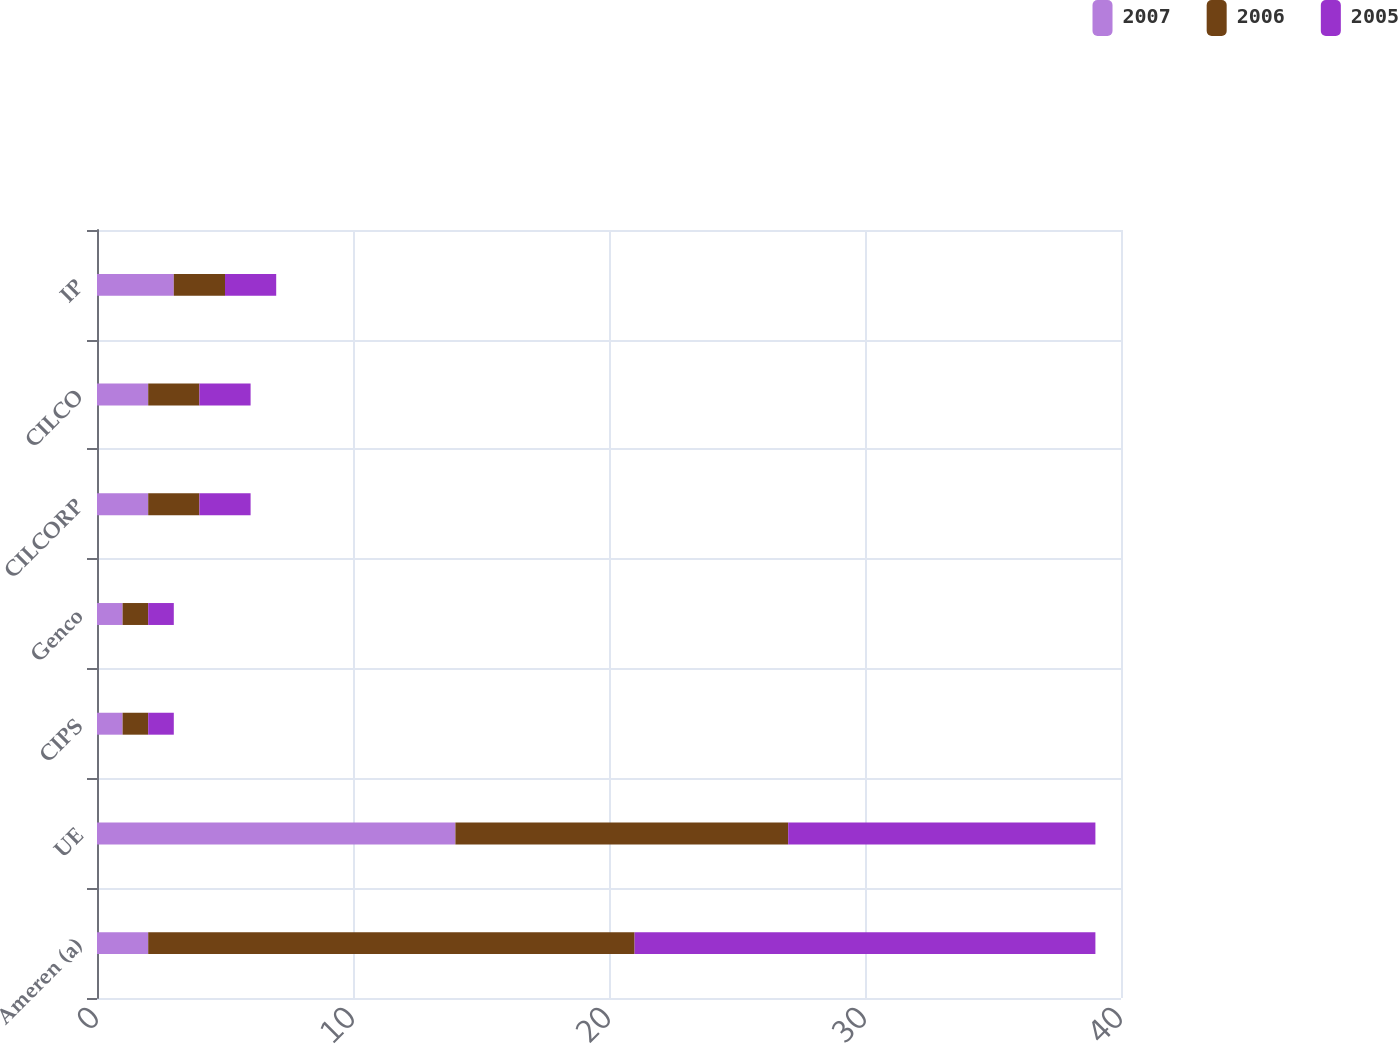Convert chart to OTSL. <chart><loc_0><loc_0><loc_500><loc_500><stacked_bar_chart><ecel><fcel>Ameren (a)<fcel>UE<fcel>CIPS<fcel>Genco<fcel>CILCORP<fcel>CILCO<fcel>IP<nl><fcel>2007<fcel>2<fcel>14<fcel>1<fcel>1<fcel>2<fcel>2<fcel>3<nl><fcel>2006<fcel>19<fcel>13<fcel>1<fcel>1<fcel>2<fcel>2<fcel>2<nl><fcel>2005<fcel>18<fcel>12<fcel>1<fcel>1<fcel>2<fcel>2<fcel>2<nl></chart> 